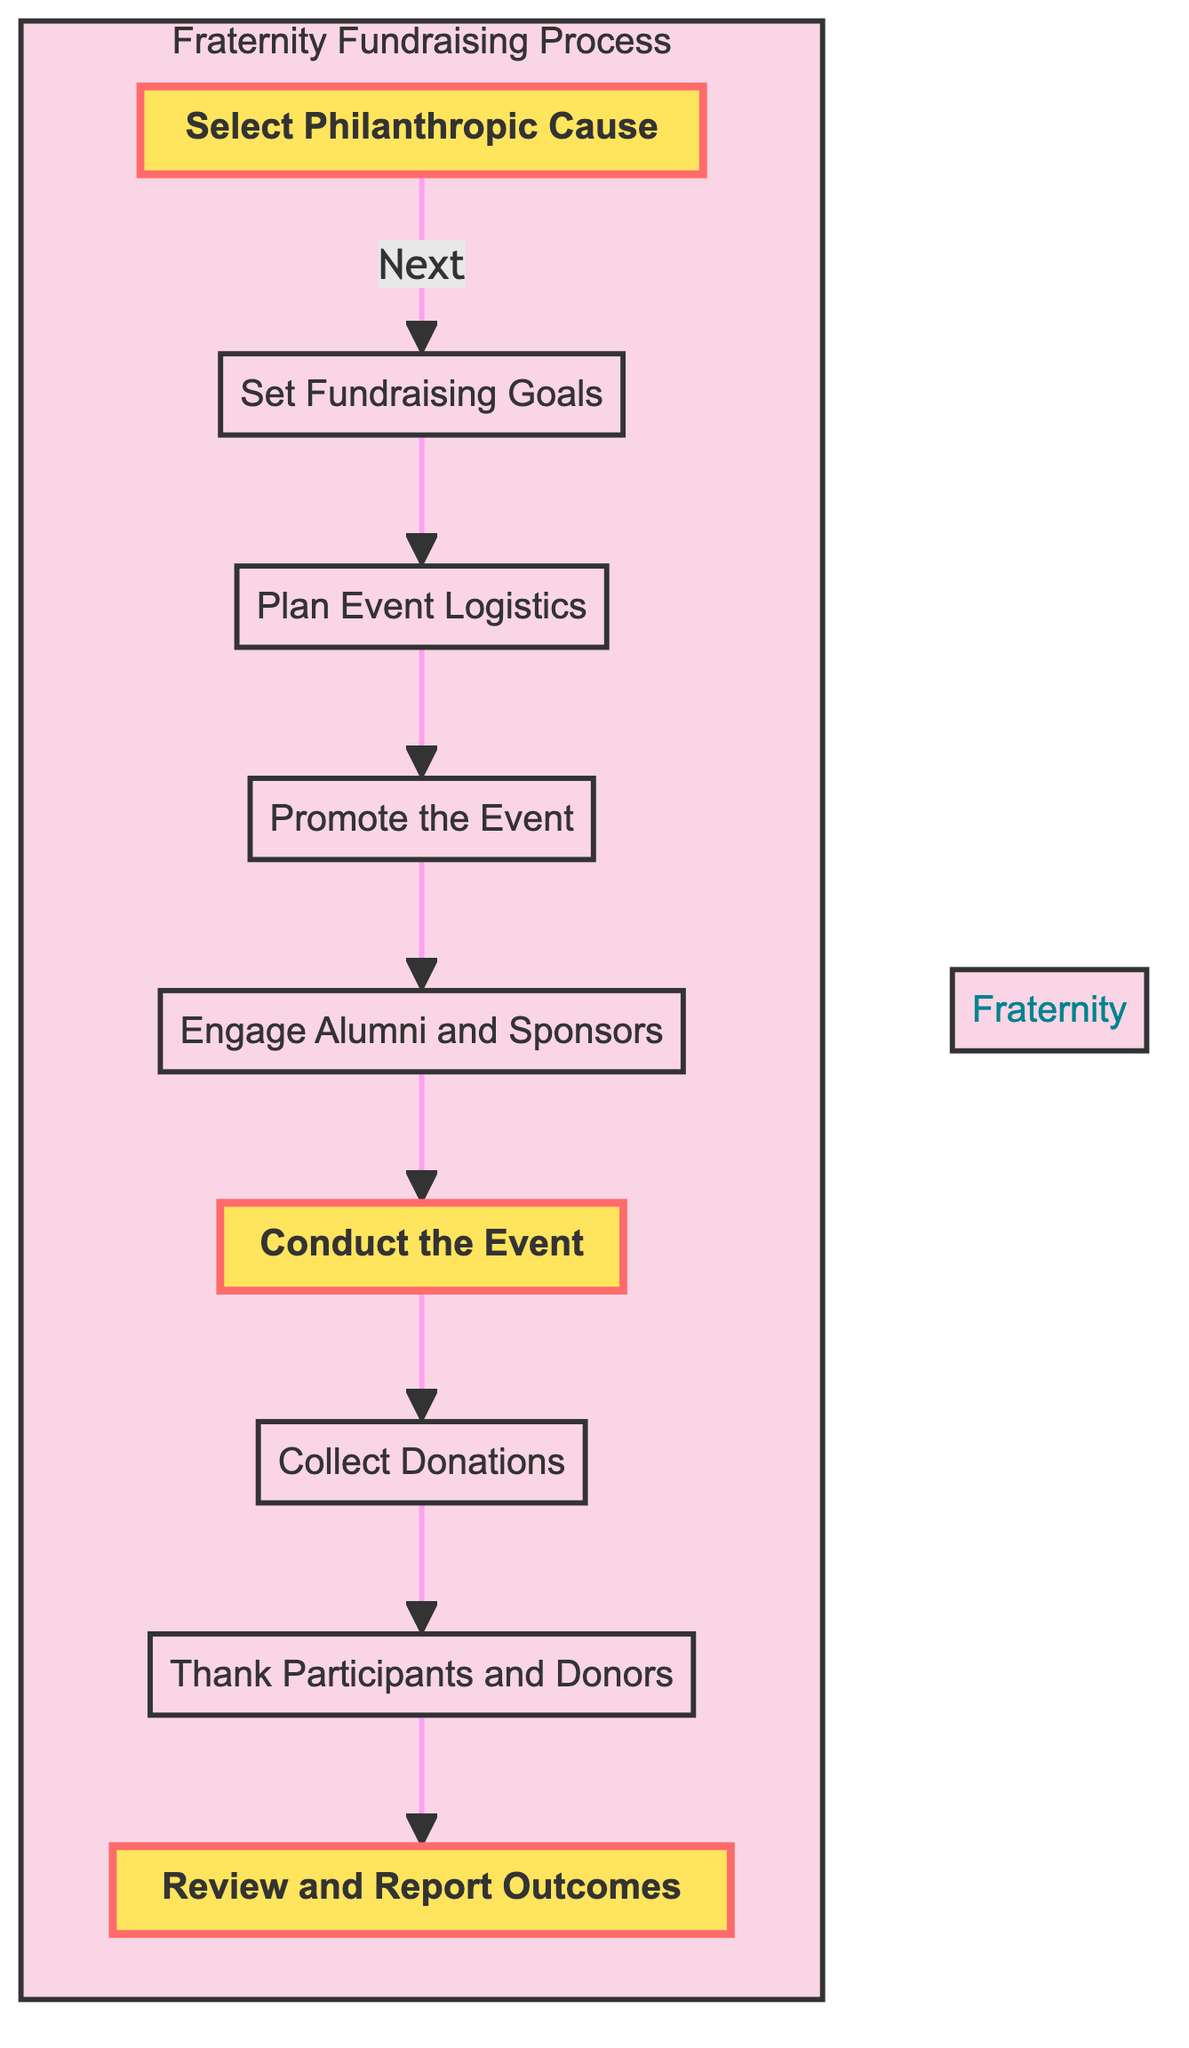What is the first step in the fundraising process? The first step in the flow is labeled "Select Philanthropic Cause." This node initiates the fundraising process by choosing a cause that aligns with the fraternity's values.
Answer: Select Philanthropic Cause How many nodes are in the fundraising process flow? By counting the distinct labeled nodes in the diagram, there are nine steps listed in the flowchart from selecting a cause to reviewing outcomes.
Answer: Nine What is the last step in the process? The last step is labeled "Review and Report Outcomes." This node concludes the process by analyzing results and reporting them to stakeholders.
Answer: Review and Report Outcomes Which step follows "Conduct the Event"? The flowchart shows that the step following "Conduct the Event" is "Collect Donations." This indicates that gathering donations occurs right after executing the event.
Answer: Collect Donations List three methods of promotion mentioned in the diagram. The diagram includes "social media," "flyers," and "fraternity networks" as methods for promoting the event, according to the description for the "Promote the Event" node.
Answer: Social media, flyers, fraternity networks How are alumni and sponsors engaged in the fundraising process? Alumni and sponsors are engaged through outreach efforts described in the "Engage Alumni and Sponsors" node, which seeks sponsorship opportunities and support for the event.
Answer: Outreach for sponsorship What is the purpose of the "Thank Participants and Donors" step? The purpose of this step is to follow up with participants and donors to express gratitude and share the impact of their contributions, highlighting its importance in building relationships.
Answer: Express gratitude and share impact Does the flowchart prioritizes any specific steps? Yes, the nodes "Select Philanthropic Cause," "Conduct the Event," and "Review and Report Outcomes" are highlighted in the diagram, indicating that they are essential steps in the fundraising process.
Answer: Yes, specific steps are highlighted 